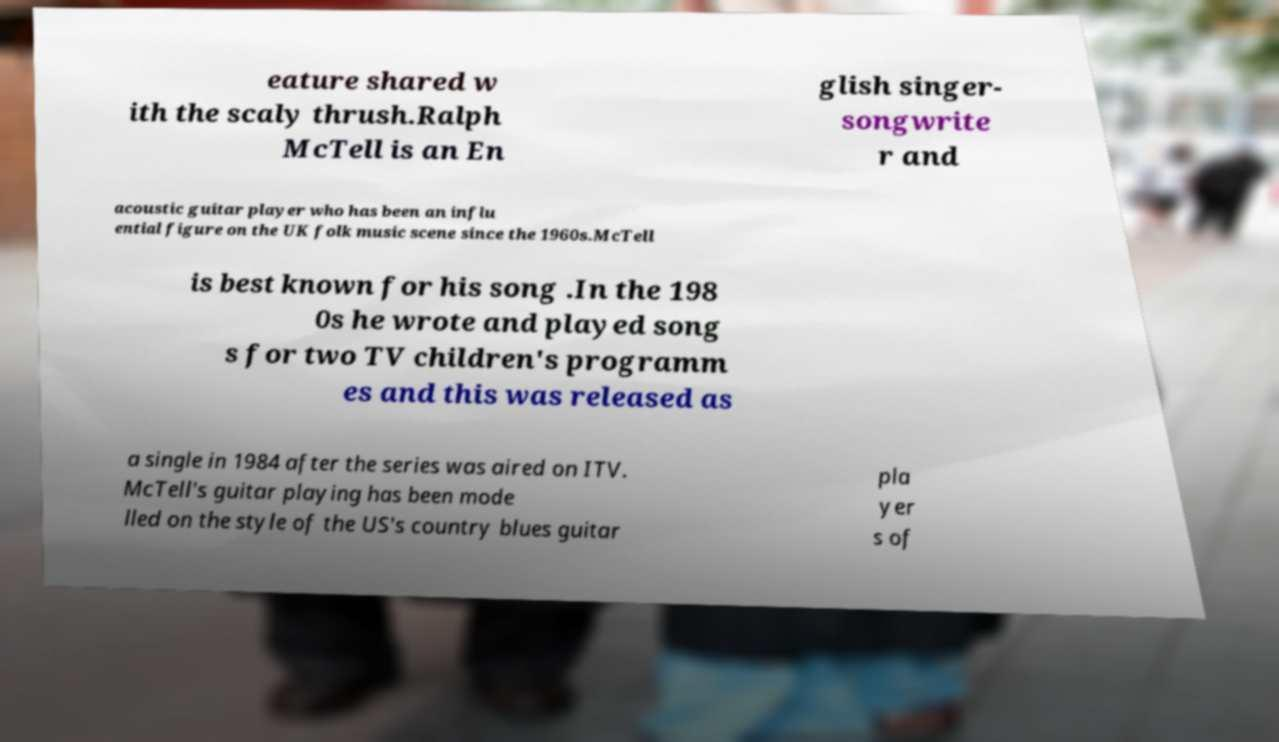For documentation purposes, I need the text within this image transcribed. Could you provide that? eature shared w ith the scaly thrush.Ralph McTell is an En glish singer- songwrite r and acoustic guitar player who has been an influ ential figure on the UK folk music scene since the 1960s.McTell is best known for his song .In the 198 0s he wrote and played song s for two TV children's programm es and this was released as a single in 1984 after the series was aired on ITV. McTell's guitar playing has been mode lled on the style of the US's country blues guitar pla yer s of 